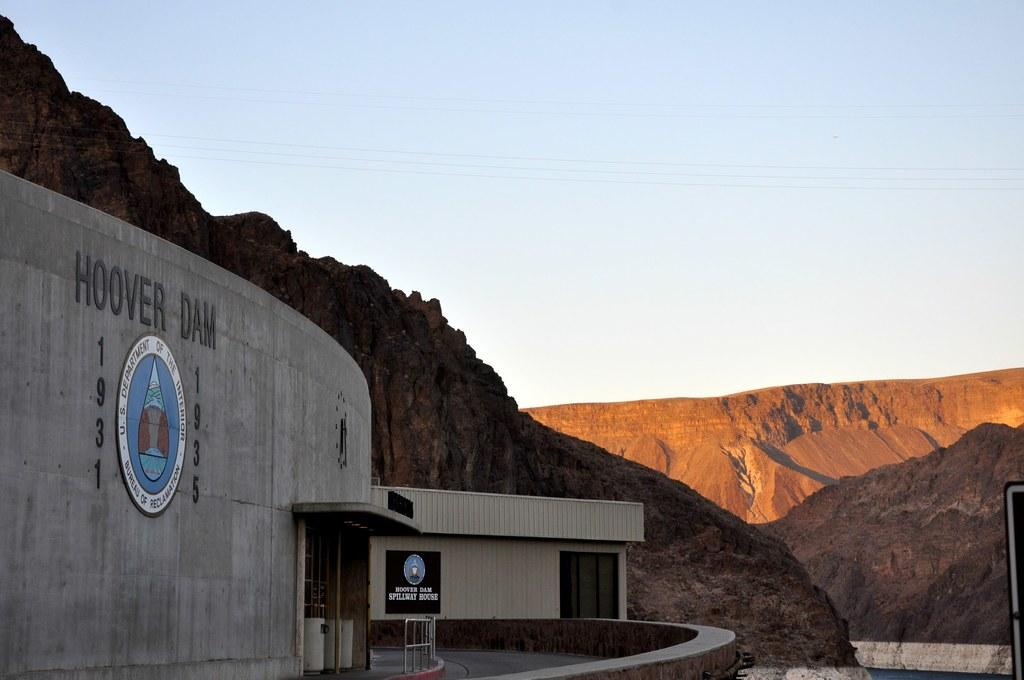What is the main subject in the foreground of the image? There is a dam in the foreground of the image. What is written on the dam? The dam has text on it that says "HOOVER DAM". What can be seen in the background of the image? There are cliffs in the background of the image. What is visible at the top of the image? There are cables and the sky visible at the top of the image. How many representatives are sitting on the seat in the image? There is no seat or representatives present in the image; it features a dam with text and cliffs in the background. 